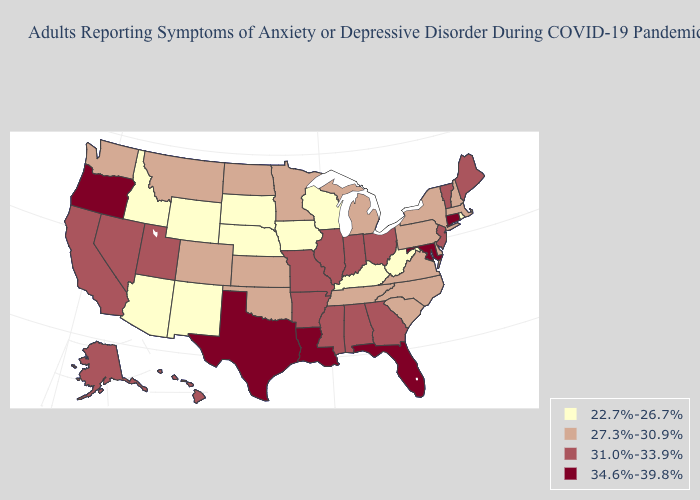Does Wyoming have the lowest value in the USA?
Concise answer only. Yes. What is the highest value in states that border Connecticut?
Be succinct. 27.3%-30.9%. Name the states that have a value in the range 34.6%-39.8%?
Give a very brief answer. Connecticut, Florida, Louisiana, Maryland, Oregon, Texas. What is the value of Louisiana?
Quick response, please. 34.6%-39.8%. Does Colorado have a higher value than Alaska?
Concise answer only. No. Among the states that border Kentucky , which have the highest value?
Give a very brief answer. Illinois, Indiana, Missouri, Ohio. What is the value of Alabama?
Write a very short answer. 31.0%-33.9%. Does Rhode Island have the lowest value in the Northeast?
Short answer required. Yes. How many symbols are there in the legend?
Answer briefly. 4. Name the states that have a value in the range 27.3%-30.9%?
Be succinct. Colorado, Delaware, Kansas, Massachusetts, Michigan, Minnesota, Montana, New Hampshire, New York, North Carolina, North Dakota, Oklahoma, Pennsylvania, South Carolina, Tennessee, Virginia, Washington. What is the value of Arizona?
Short answer required. 22.7%-26.7%. Which states have the highest value in the USA?
Give a very brief answer. Connecticut, Florida, Louisiana, Maryland, Oregon, Texas. How many symbols are there in the legend?
Concise answer only. 4. What is the value of West Virginia?
Keep it brief. 22.7%-26.7%. Does Utah have a lower value than Florida?
Short answer required. Yes. 